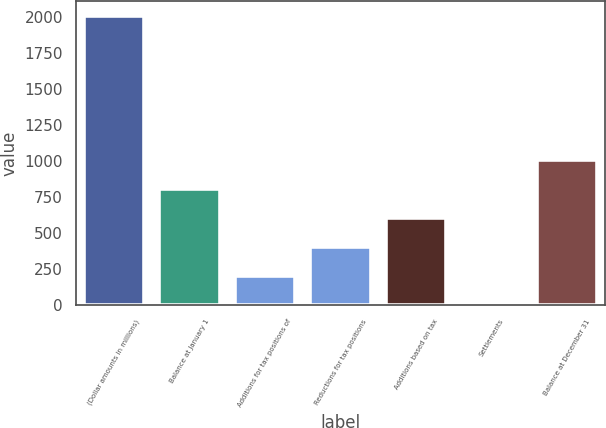<chart> <loc_0><loc_0><loc_500><loc_500><bar_chart><fcel>(Dollar amounts in millions)<fcel>Balance at January 1<fcel>Additions for tax positions of<fcel>Reductions for tax positions<fcel>Additions based on tax<fcel>Settlements<fcel>Balance at December 31<nl><fcel>2010<fcel>805.2<fcel>202.8<fcel>403.6<fcel>604.4<fcel>2<fcel>1006<nl></chart> 